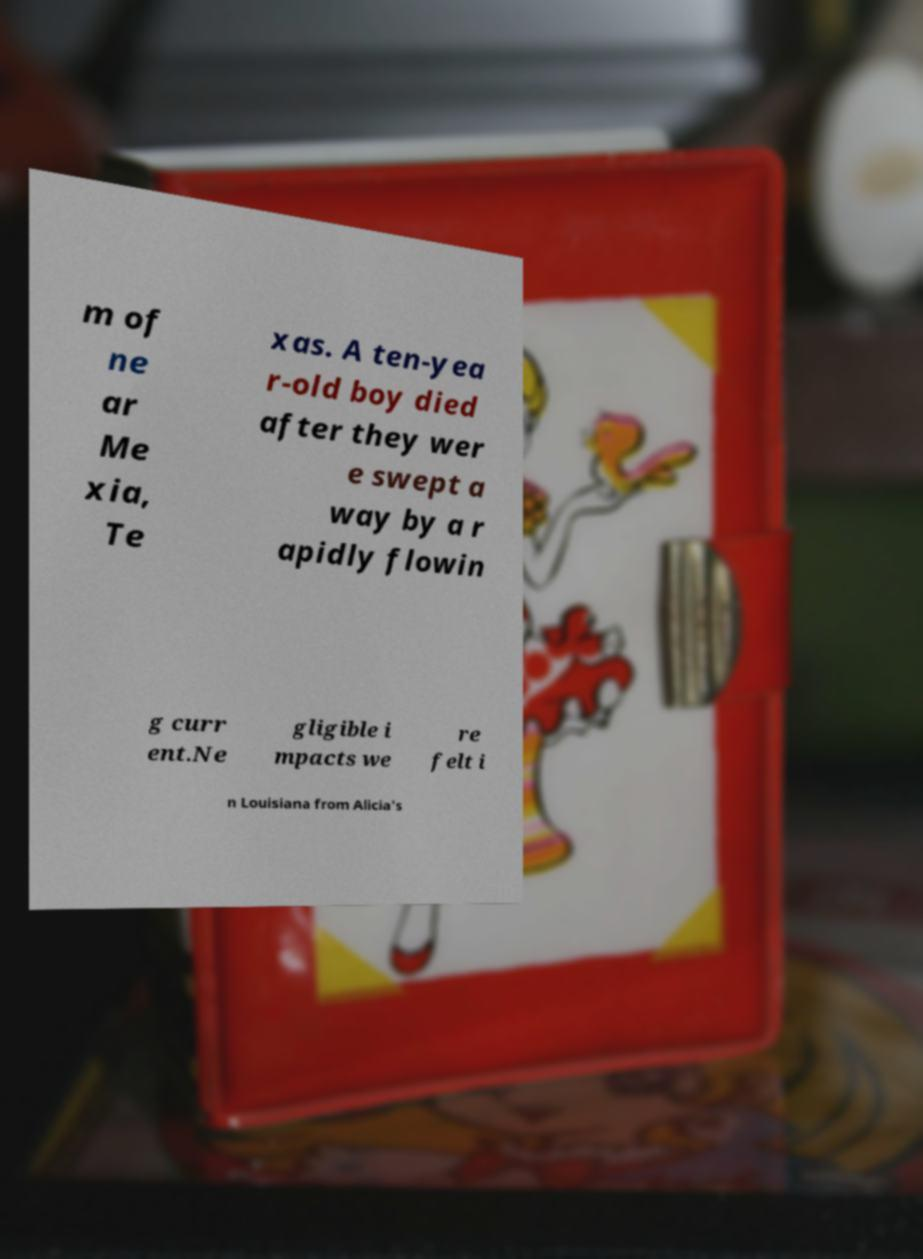Please identify and transcribe the text found in this image. m of ne ar Me xia, Te xas. A ten-yea r-old boy died after they wer e swept a way by a r apidly flowin g curr ent.Ne gligible i mpacts we re felt i n Louisiana from Alicia's 